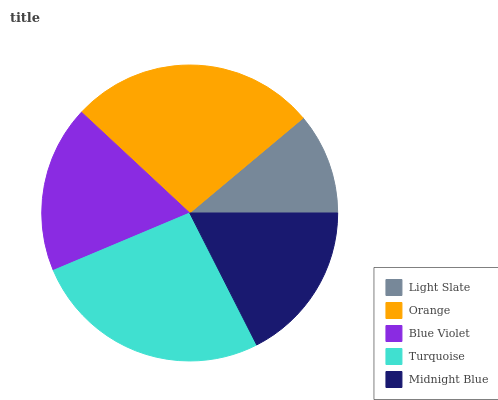Is Light Slate the minimum?
Answer yes or no. Yes. Is Orange the maximum?
Answer yes or no. Yes. Is Blue Violet the minimum?
Answer yes or no. No. Is Blue Violet the maximum?
Answer yes or no. No. Is Orange greater than Blue Violet?
Answer yes or no. Yes. Is Blue Violet less than Orange?
Answer yes or no. Yes. Is Blue Violet greater than Orange?
Answer yes or no. No. Is Orange less than Blue Violet?
Answer yes or no. No. Is Blue Violet the high median?
Answer yes or no. Yes. Is Blue Violet the low median?
Answer yes or no. Yes. Is Turquoise the high median?
Answer yes or no. No. Is Orange the low median?
Answer yes or no. No. 